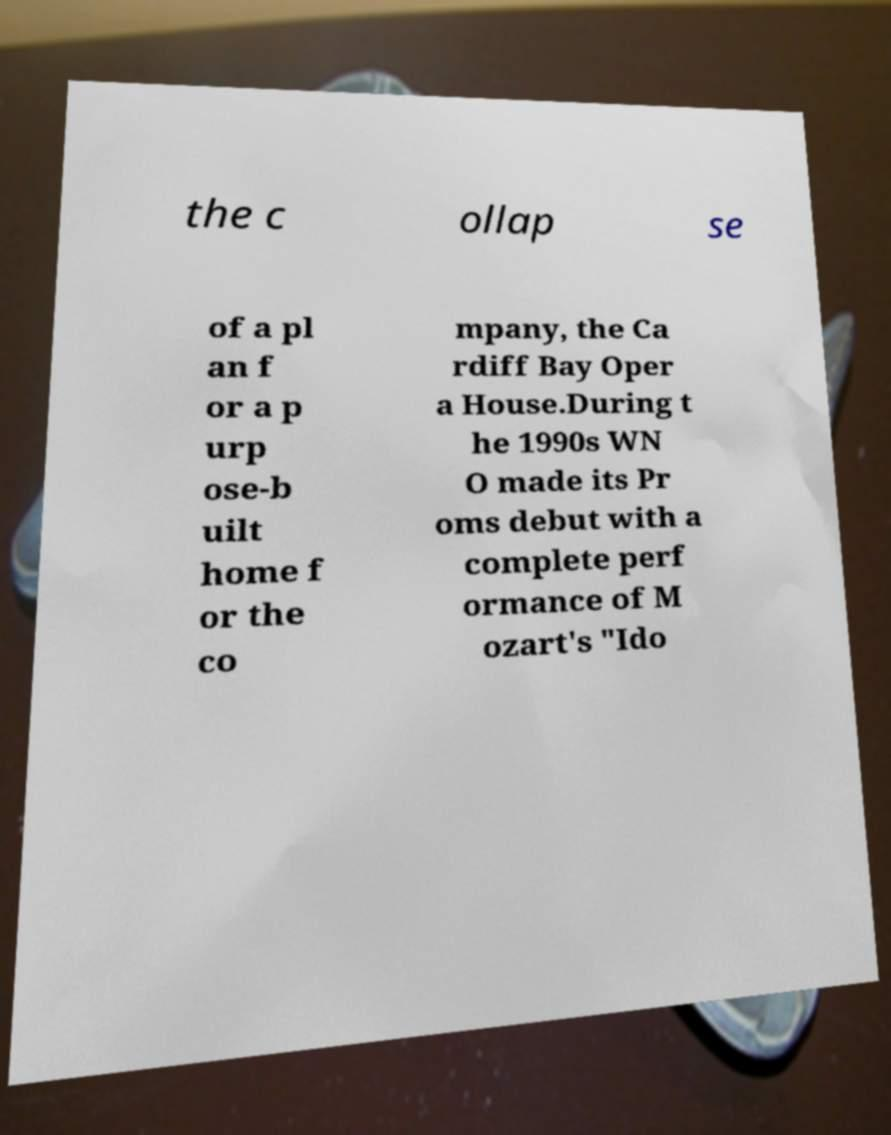Please identify and transcribe the text found in this image. the c ollap se of a pl an f or a p urp ose-b uilt home f or the co mpany, the Ca rdiff Bay Oper a House.During t he 1990s WN O made its Pr oms debut with a complete perf ormance of M ozart's "Ido 